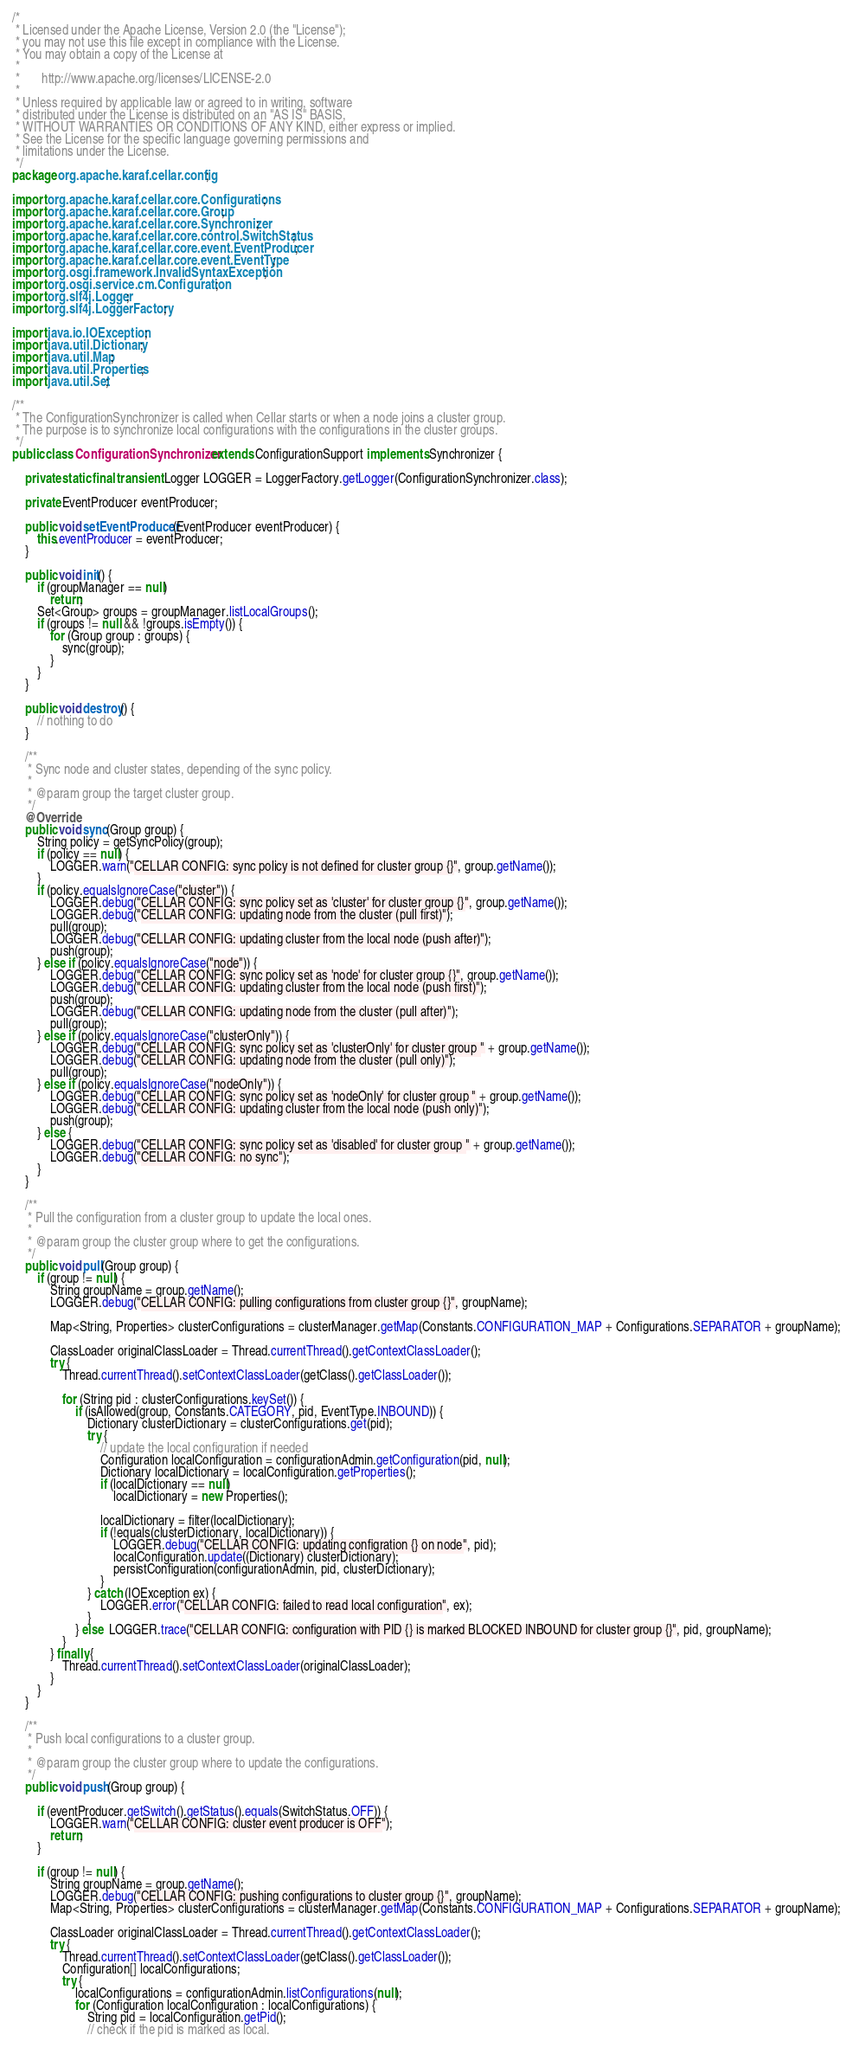<code> <loc_0><loc_0><loc_500><loc_500><_Java_>/*
 * Licensed under the Apache License, Version 2.0 (the "License");
 * you may not use this file except in compliance with the License.
 * You may obtain a copy of the License at
 *
 *       http://www.apache.org/licenses/LICENSE-2.0
 *
 * Unless required by applicable law or agreed to in writing, software
 * distributed under the License is distributed on an "AS IS" BASIS,
 * WITHOUT WARRANTIES OR CONDITIONS OF ANY KIND, either express or implied.
 * See the License for the specific language governing permissions and
 * limitations under the License.
 */
package org.apache.karaf.cellar.config;

import org.apache.karaf.cellar.core.Configurations;
import org.apache.karaf.cellar.core.Group;
import org.apache.karaf.cellar.core.Synchronizer;
import org.apache.karaf.cellar.core.control.SwitchStatus;
import org.apache.karaf.cellar.core.event.EventProducer;
import org.apache.karaf.cellar.core.event.EventType;
import org.osgi.framework.InvalidSyntaxException;
import org.osgi.service.cm.Configuration;
import org.slf4j.Logger;
import org.slf4j.LoggerFactory;

import java.io.IOException;
import java.util.Dictionary;
import java.util.Map;
import java.util.Properties;
import java.util.Set;

/**
 * The ConfigurationSynchronizer is called when Cellar starts or when a node joins a cluster group.
 * The purpose is to synchronize local configurations with the configurations in the cluster groups.
 */
public class ConfigurationSynchronizer extends ConfigurationSupport implements Synchronizer {

    private static final transient Logger LOGGER = LoggerFactory.getLogger(ConfigurationSynchronizer.class);

    private EventProducer eventProducer;

    public void setEventProducer(EventProducer eventProducer) {
        this.eventProducer = eventProducer;
    }

    public void init() {
        if (groupManager == null)
            return;
        Set<Group> groups = groupManager.listLocalGroups();
        if (groups != null && !groups.isEmpty()) {
            for (Group group : groups) {
                sync(group);
            }
        }
    }

    public void destroy() {
        // nothing to do
    }

    /**
     * Sync node and cluster states, depending of the sync policy.
     *
     * @param group the target cluster group.
     */
    @Override
    public void sync(Group group) {
        String policy = getSyncPolicy(group);
        if (policy == null) {
            LOGGER.warn("CELLAR CONFIG: sync policy is not defined for cluster group {}", group.getName());
        }
        if (policy.equalsIgnoreCase("cluster")) {
            LOGGER.debug("CELLAR CONFIG: sync policy set as 'cluster' for cluster group {}", group.getName());
            LOGGER.debug("CELLAR CONFIG: updating node from the cluster (pull first)");
            pull(group);
            LOGGER.debug("CELLAR CONFIG: updating cluster from the local node (push after)");
            push(group);
        } else if (policy.equalsIgnoreCase("node")) {
            LOGGER.debug("CELLAR CONFIG: sync policy set as 'node' for cluster group {}", group.getName());
            LOGGER.debug("CELLAR CONFIG: updating cluster from the local node (push first)");
            push(group);
            LOGGER.debug("CELLAR CONFIG: updating node from the cluster (pull after)");
            pull(group);
        } else if (policy.equalsIgnoreCase("clusterOnly")) {
            LOGGER.debug("CELLAR CONFIG: sync policy set as 'clusterOnly' for cluster group " + group.getName());
            LOGGER.debug("CELLAR CONFIG: updating node from the cluster (pull only)");
            pull(group);
        } else if (policy.equalsIgnoreCase("nodeOnly")) {
            LOGGER.debug("CELLAR CONFIG: sync policy set as 'nodeOnly' for cluster group " + group.getName());
            LOGGER.debug("CELLAR CONFIG: updating cluster from the local node (push only)");
            push(group);
        } else {
            LOGGER.debug("CELLAR CONFIG: sync policy set as 'disabled' for cluster group " + group.getName());
            LOGGER.debug("CELLAR CONFIG: no sync");
        }
    }

    /**
     * Pull the configuration from a cluster group to update the local ones.
     *
     * @param group the cluster group where to get the configurations.
     */
    public void pull(Group group) {
        if (group != null) {
            String groupName = group.getName();
            LOGGER.debug("CELLAR CONFIG: pulling configurations from cluster group {}", groupName);

            Map<String, Properties> clusterConfigurations = clusterManager.getMap(Constants.CONFIGURATION_MAP + Configurations.SEPARATOR + groupName);

            ClassLoader originalClassLoader = Thread.currentThread().getContextClassLoader();
            try {
                Thread.currentThread().setContextClassLoader(getClass().getClassLoader());

                for (String pid : clusterConfigurations.keySet()) {
                    if (isAllowed(group, Constants.CATEGORY, pid, EventType.INBOUND)) {
                        Dictionary clusterDictionary = clusterConfigurations.get(pid);
                        try {
                            // update the local configuration if needed
                            Configuration localConfiguration = configurationAdmin.getConfiguration(pid, null);
                            Dictionary localDictionary = localConfiguration.getProperties();
                            if (localDictionary == null)
                                localDictionary = new Properties();

                            localDictionary = filter(localDictionary);
                            if (!equals(clusterDictionary, localDictionary)) {
                                LOGGER.debug("CELLAR CONFIG: updating configration {} on node", pid);
                                localConfiguration.update((Dictionary) clusterDictionary);
                                persistConfiguration(configurationAdmin, pid, clusterDictionary);
                            }
                        } catch (IOException ex) {
                            LOGGER.error("CELLAR CONFIG: failed to read local configuration", ex);
                        }
                    } else  LOGGER.trace("CELLAR CONFIG: configuration with PID {} is marked BLOCKED INBOUND for cluster group {}", pid, groupName);
                }
            } finally {
                Thread.currentThread().setContextClassLoader(originalClassLoader);
            }
        }
    }

    /**
     * Push local configurations to a cluster group.
     *
     * @param group the cluster group where to update the configurations.
     */
    public void push(Group group) {

        if (eventProducer.getSwitch().getStatus().equals(SwitchStatus.OFF)) {
            LOGGER.warn("CELLAR CONFIG: cluster event producer is OFF");
            return;
        }

        if (group != null) {
            String groupName = group.getName();
            LOGGER.debug("CELLAR CONFIG: pushing configurations to cluster group {}", groupName);
            Map<String, Properties> clusterConfigurations = clusterManager.getMap(Constants.CONFIGURATION_MAP + Configurations.SEPARATOR + groupName);

            ClassLoader originalClassLoader = Thread.currentThread().getContextClassLoader();
            try {
                Thread.currentThread().setContextClassLoader(getClass().getClassLoader());
                Configuration[] localConfigurations;
                try {
                    localConfigurations = configurationAdmin.listConfigurations(null);
                    for (Configuration localConfiguration : localConfigurations) {
                        String pid = localConfiguration.getPid();
                        // check if the pid is marked as local.</code> 